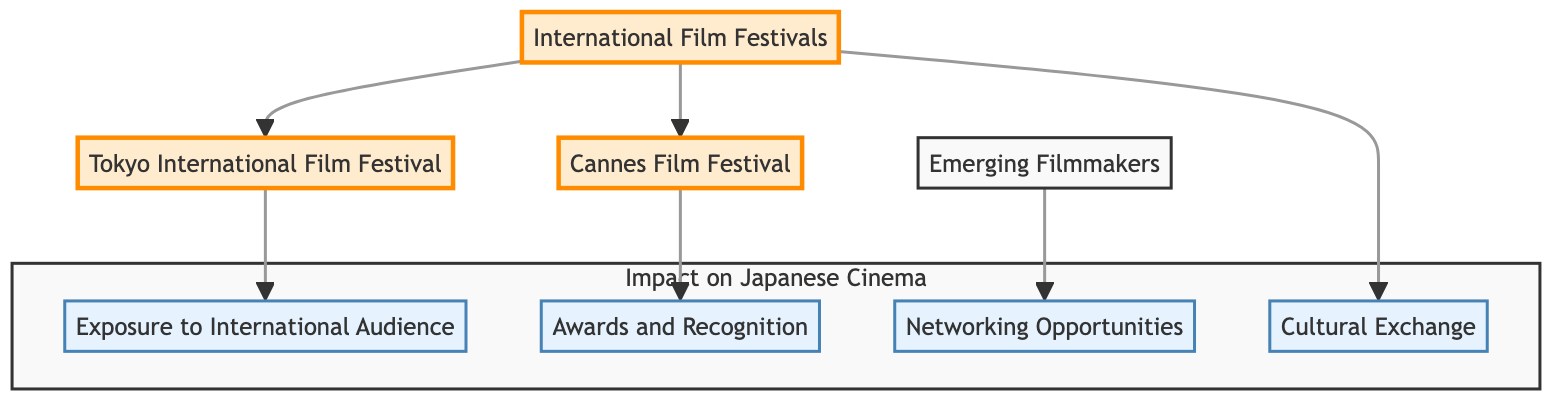What are two major international film festivals mentioned in the diagram? The diagram lists "Tokyo International Film Festival" and "Cannes Film Festival" as key nodes connected to "International Film Festivals." These are the two festivals highlighted in the context of Japanese cinema.
Answer: Tokyo International Film Festival, Cannes Film Festival What impact does the Tokyo International Film Festival provide to filmmakers? According to the diagram, the Tokyo International Film Festival leads to "Exposure to International Audience." This indicates its role in connecting filmmakers with global viewers.
Answer: Exposure to International Audience What type of opportunity does "Networking Opportunities" refer to in the flowchart? "Networking Opportunities" is positioned under "Emerging Filmmakers," implying that it refers to the potential collaborations and connections that new talents can forge at film festivals.
Answer: Connections and collaborations How many nodes are there in the entire flow chart? By counting the nodes listed in the diagram, there are a total of eight nodes: International Film Festivals, Tokyo International Film Festival, Cannes Film Festival, Emerging Filmmakers, Exposure to International Audience, Awards and Recognition, Networking Opportunities, and Cultural Exchange.
Answer: Eight What is the relationship between "Cannes Film Festival" and "Awards and Recognition"? The flowchart shows a direct connection where "Cannes Film Festival" leads to "Awards and Recognition," indicating that this festival provides opportunities for gaining recognition and awards for films screened there.
Answer: Cannes Film Festival leads to Awards and Recognition How do international film festivals influence "Cultural Exchange"? "Cultural Exchange" is linked directly to "International Film Festivals," showing that these festivals facilitate the exchange of ideas and cultural influences between Japanese cinema and global trends.
Answer: Facilitate cultural exchange Which node leads to "Emerging Filmmakers"? The diagram indicates that "Emerging Filmmakers" is a standalone node. However, it is connected to "Networking Opportunities," which implies that the latter is the direct impact for emerging filmmakers from festivals.
Answer: Networking Opportunities What is the focus of the subgraph labeled "Impact on Japanese Cinema"? The subgraph includes nodes such as "Exposure to International Audience," "Awards and Recognition," "Networking Opportunities," and "Cultural Exchange," indicating that it focuses on the various effects that international film festivals have on Japanese cinema.
Answer: Effects on Japanese cinema 